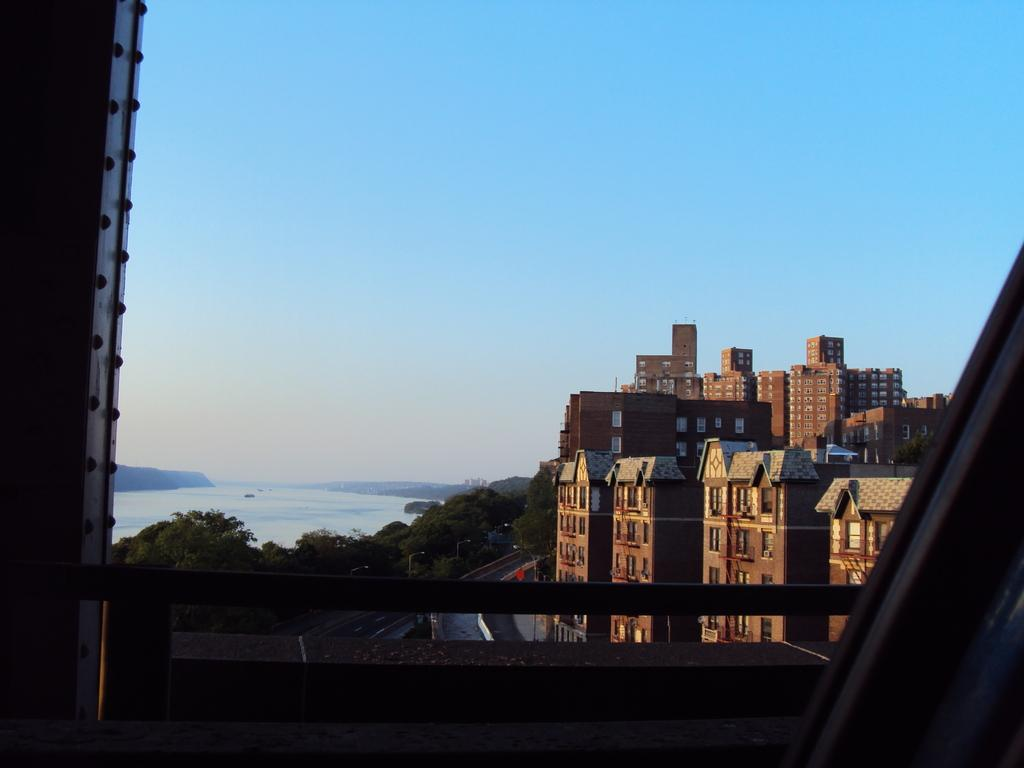What type of structures can be seen in the image? There are buildings in the image. What is located on the left side of the image? There are trees and water on the left side of the image. What is visible at the top of the image? The sky is visible at the top of the image. How many planes can be seen in the image? There are no planes visible in the image. Is there a visitor standing near the trees on the left side of the image? There is no mention of a visitor in the image, only trees and water are present on the left side. 